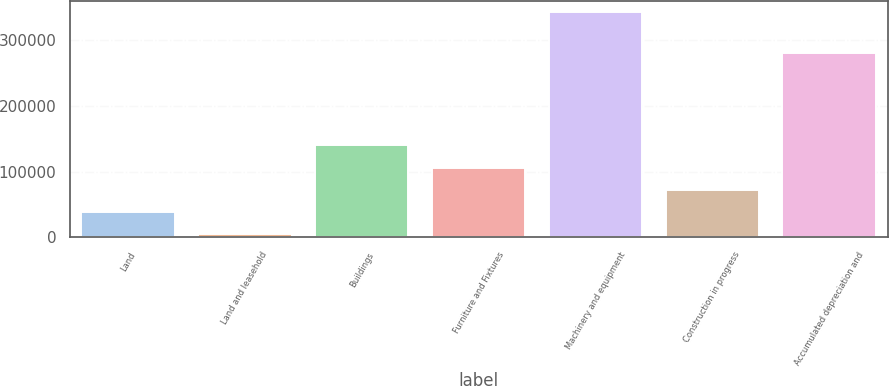<chart> <loc_0><loc_0><loc_500><loc_500><bar_chart><fcel>Land<fcel>Land and leasehold<fcel>Buildings<fcel>Furniture and Fixtures<fcel>Machinery and equipment<fcel>Construction in progress<fcel>Accumulated depreciation and<nl><fcel>38309.7<fcel>4394<fcel>140057<fcel>106141<fcel>343551<fcel>72225.4<fcel>280738<nl></chart> 